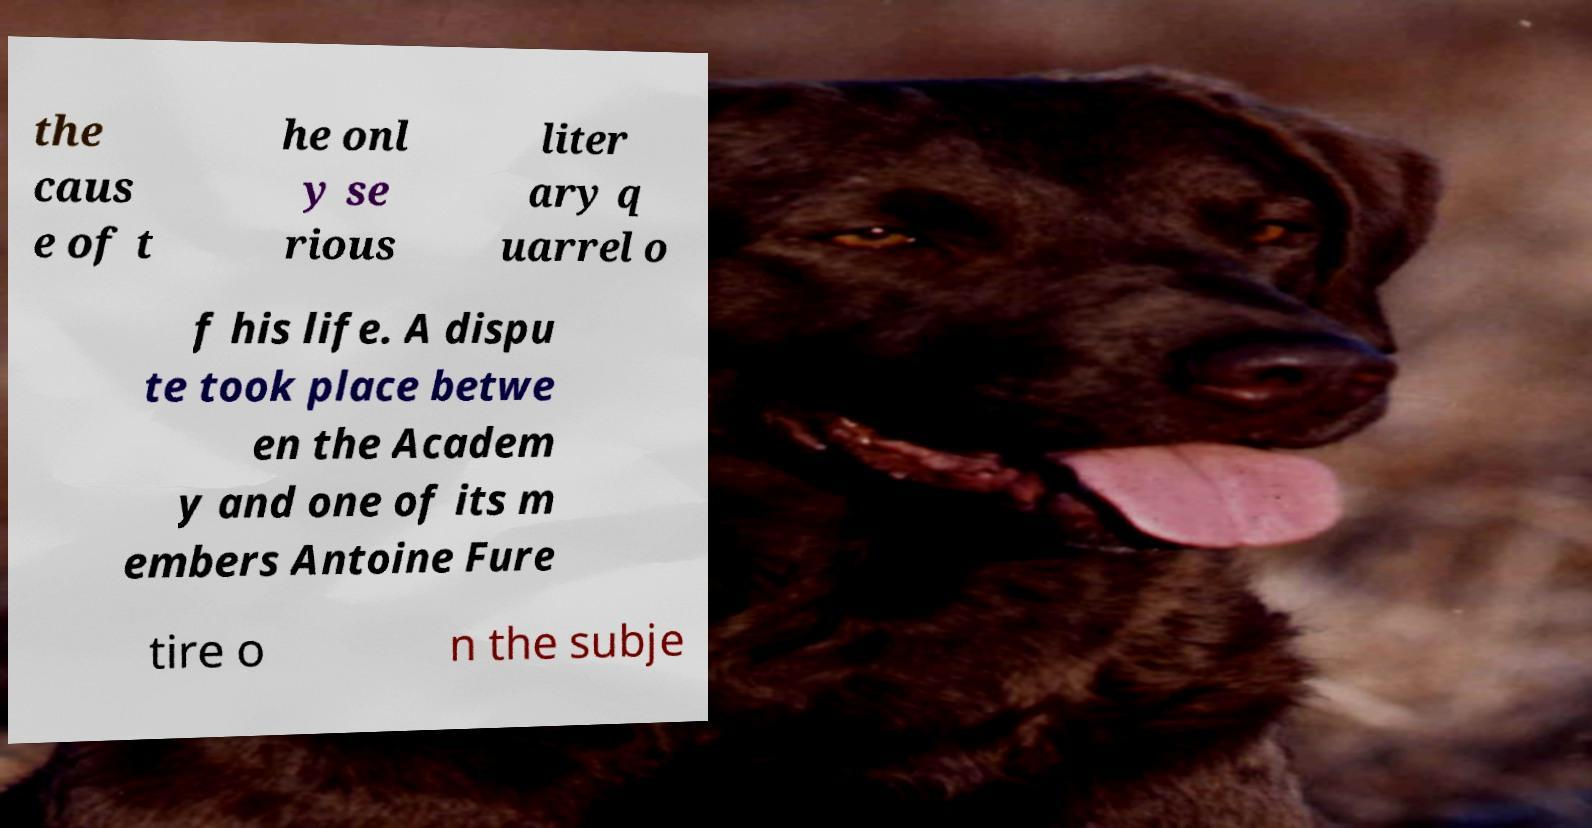Please read and relay the text visible in this image. What does it say? the caus e of t he onl y se rious liter ary q uarrel o f his life. A dispu te took place betwe en the Academ y and one of its m embers Antoine Fure tire o n the subje 